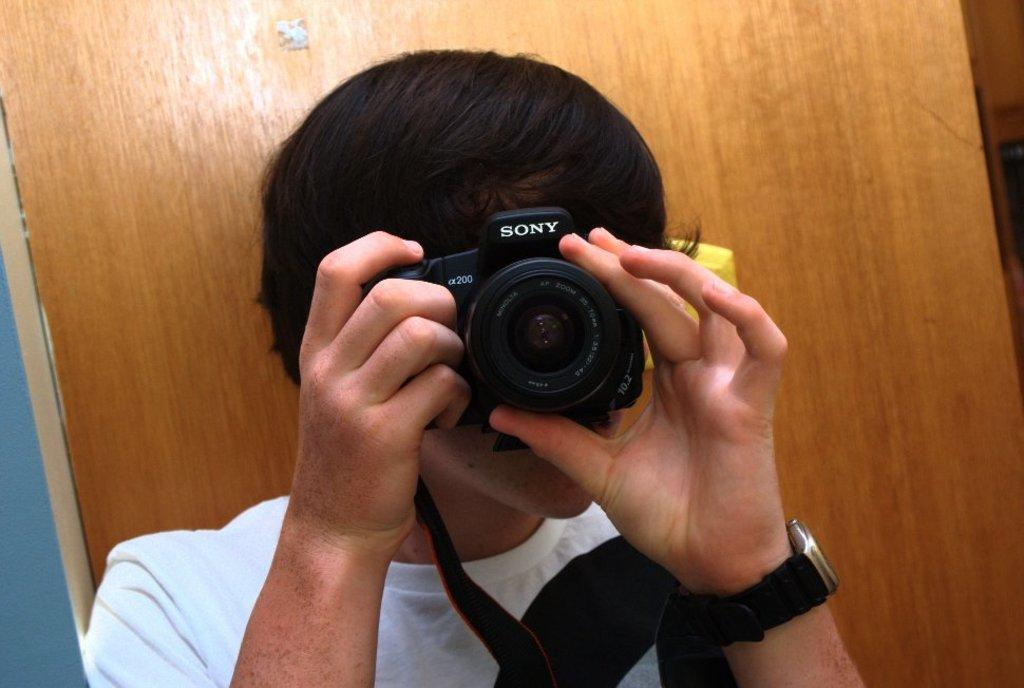What is the main subject of the image? The main subject of the image is a man. What is the man wearing in the image? The man is wearing a white t-shirt. What is the man holding in the image? The man is holding a camera. What is the man trying to do with the camera? The man appears to be attempting to take a photograph with the camera. What type of linen is draped over the man's shoulder in the image? There is no linen draped over the man's shoulder in the image. What suggestion does the man have for improving the photograph in the image? A: The image does not show any suggestions or communication from the man regarding the photograph. 